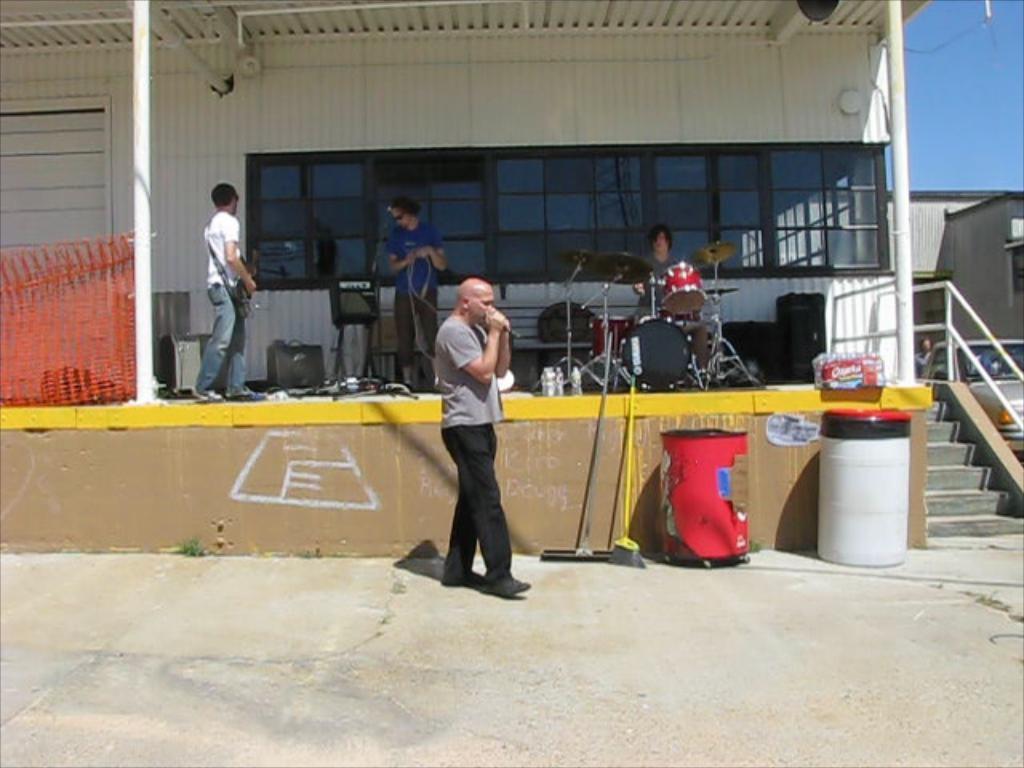Please provide a concise description of this image. In the center of the image a man is standing and holding a mic in his hand. In the middle of the image three persons are there. Left person is carrying a guitar, middle person is holding a wire in his hand, third person is sitting and playing a drums. In the background of the image there is a wall. On the left side of the image mesh is present. At the bottom of the image ground is there. On the right side of the image we can see the containers, wipers are present. On the left side of the image car, stairs and pole are there. At the top right corner sky is present. 